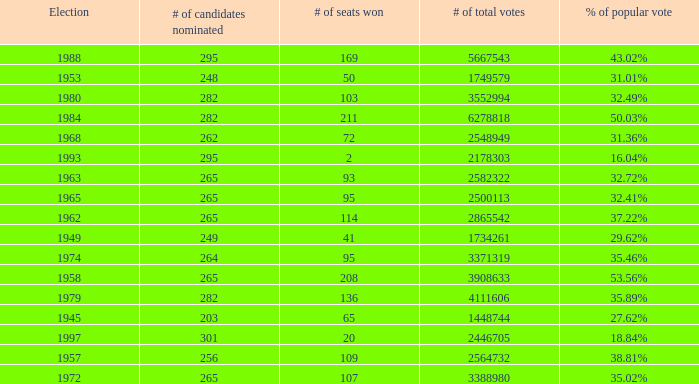What was the lowest # of total votes? 1448744.0. 